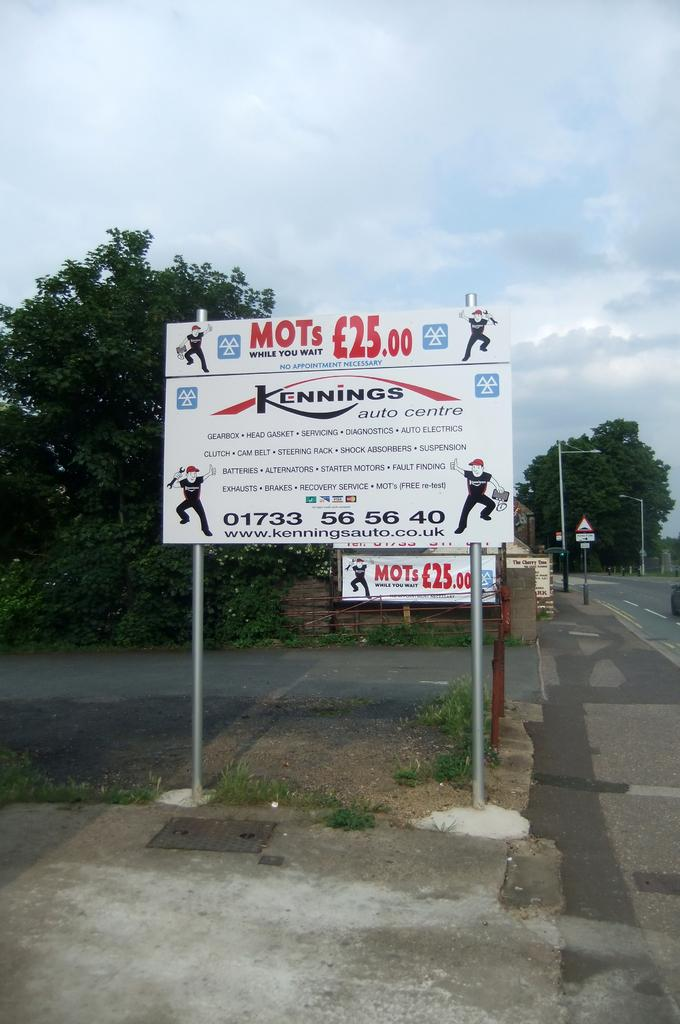<image>
Write a terse but informative summary of the picture. A sign showing MOTs while you wait for twenty five pounds. 